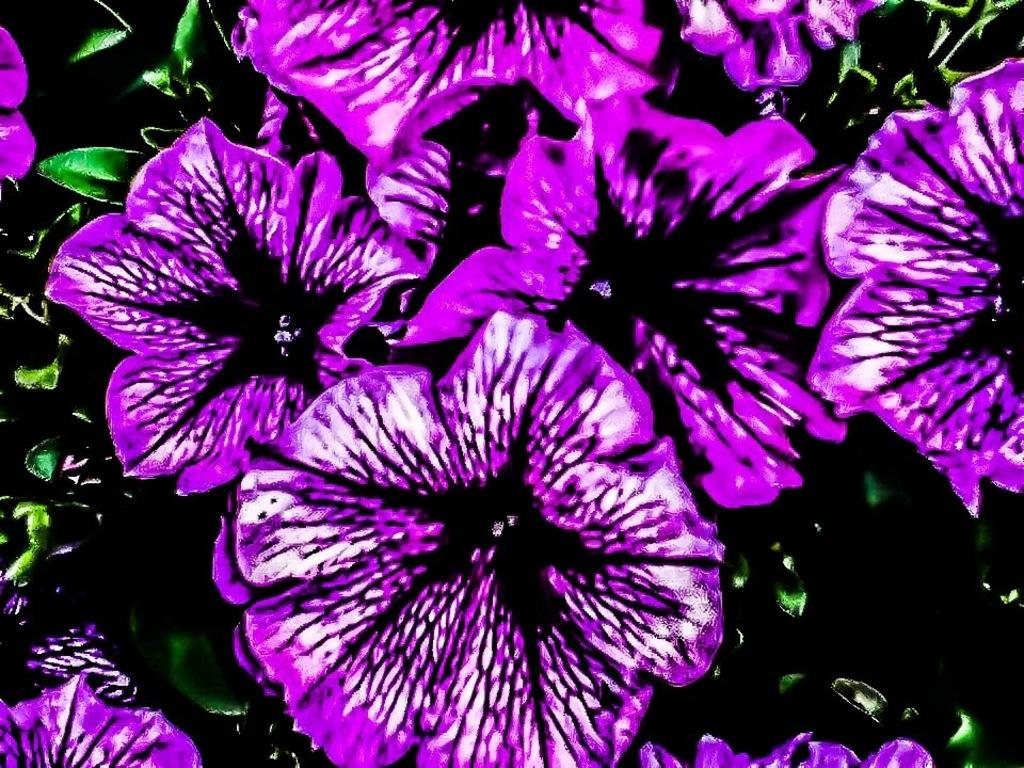What type of flowers are present in the image? There are violet flowers in the image. What other plant elements can be seen in the image besides the flowers? There are green leaves in the image. What color is the background of the image? The background of the image is black. Can you see a flame burning in the image? No, there is no flame present in the image. 